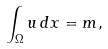<formula> <loc_0><loc_0><loc_500><loc_500>\int _ { \Omega } u \, d x = m ,</formula> 